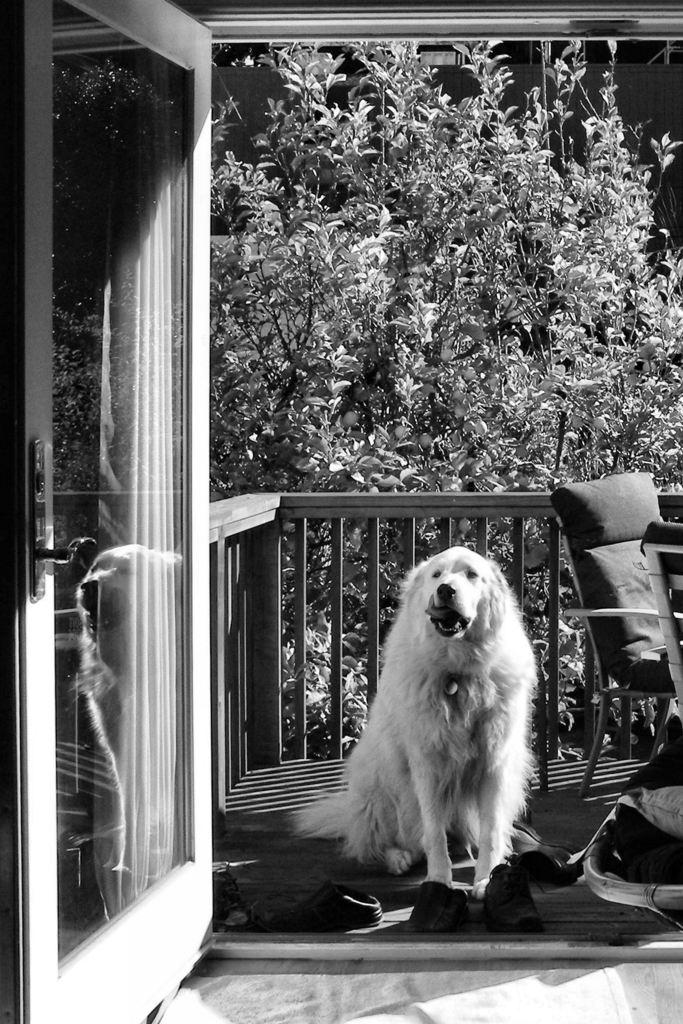What is the main subject in the center of the image? There is a dog in the center of the image. What object can be seen on the right side of the image? There is a chair on the right side of the image. What items are located at the bottom of the image? There are shoes at the bottom of the image. What structure is visible in the image? There is a door visible in the image. What type of natural scenery can be seen in the background of the image? There are trees and a fence in the background of the image. What type of cake is being served at the event in the image? There is no event or cake present in the image; it features a dog, a chair, shoes, a door, trees, and a fence. 